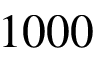<formula> <loc_0><loc_0><loc_500><loc_500>1 0 0 0</formula> 